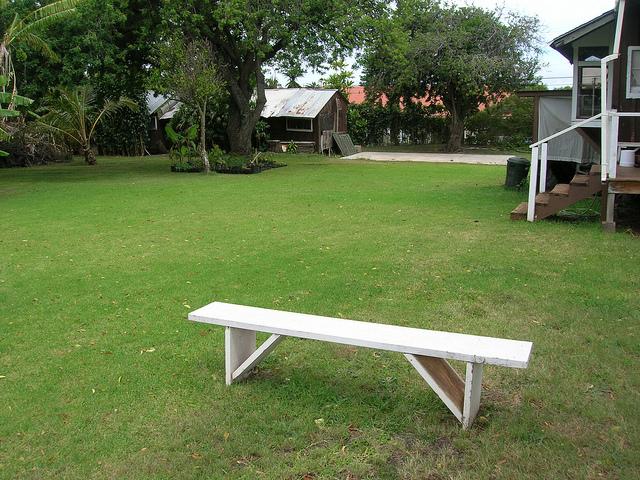Is the design of the bench ergonomic?
Concise answer only. No. Is this a park bench?
Give a very brief answer. No. What is the bench made of?
Give a very brief answer. Wood. What is the plant the bench sits on called?
Quick response, please. Grass. 